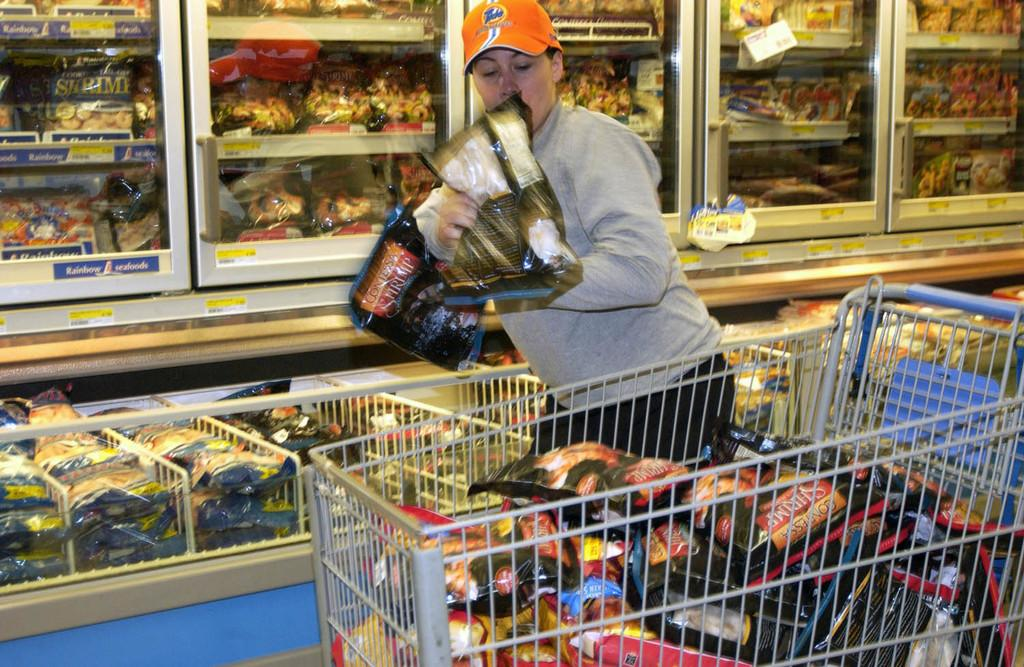<image>
Provide a brief description of the given image. the word shrimp is on one of the items at the store 